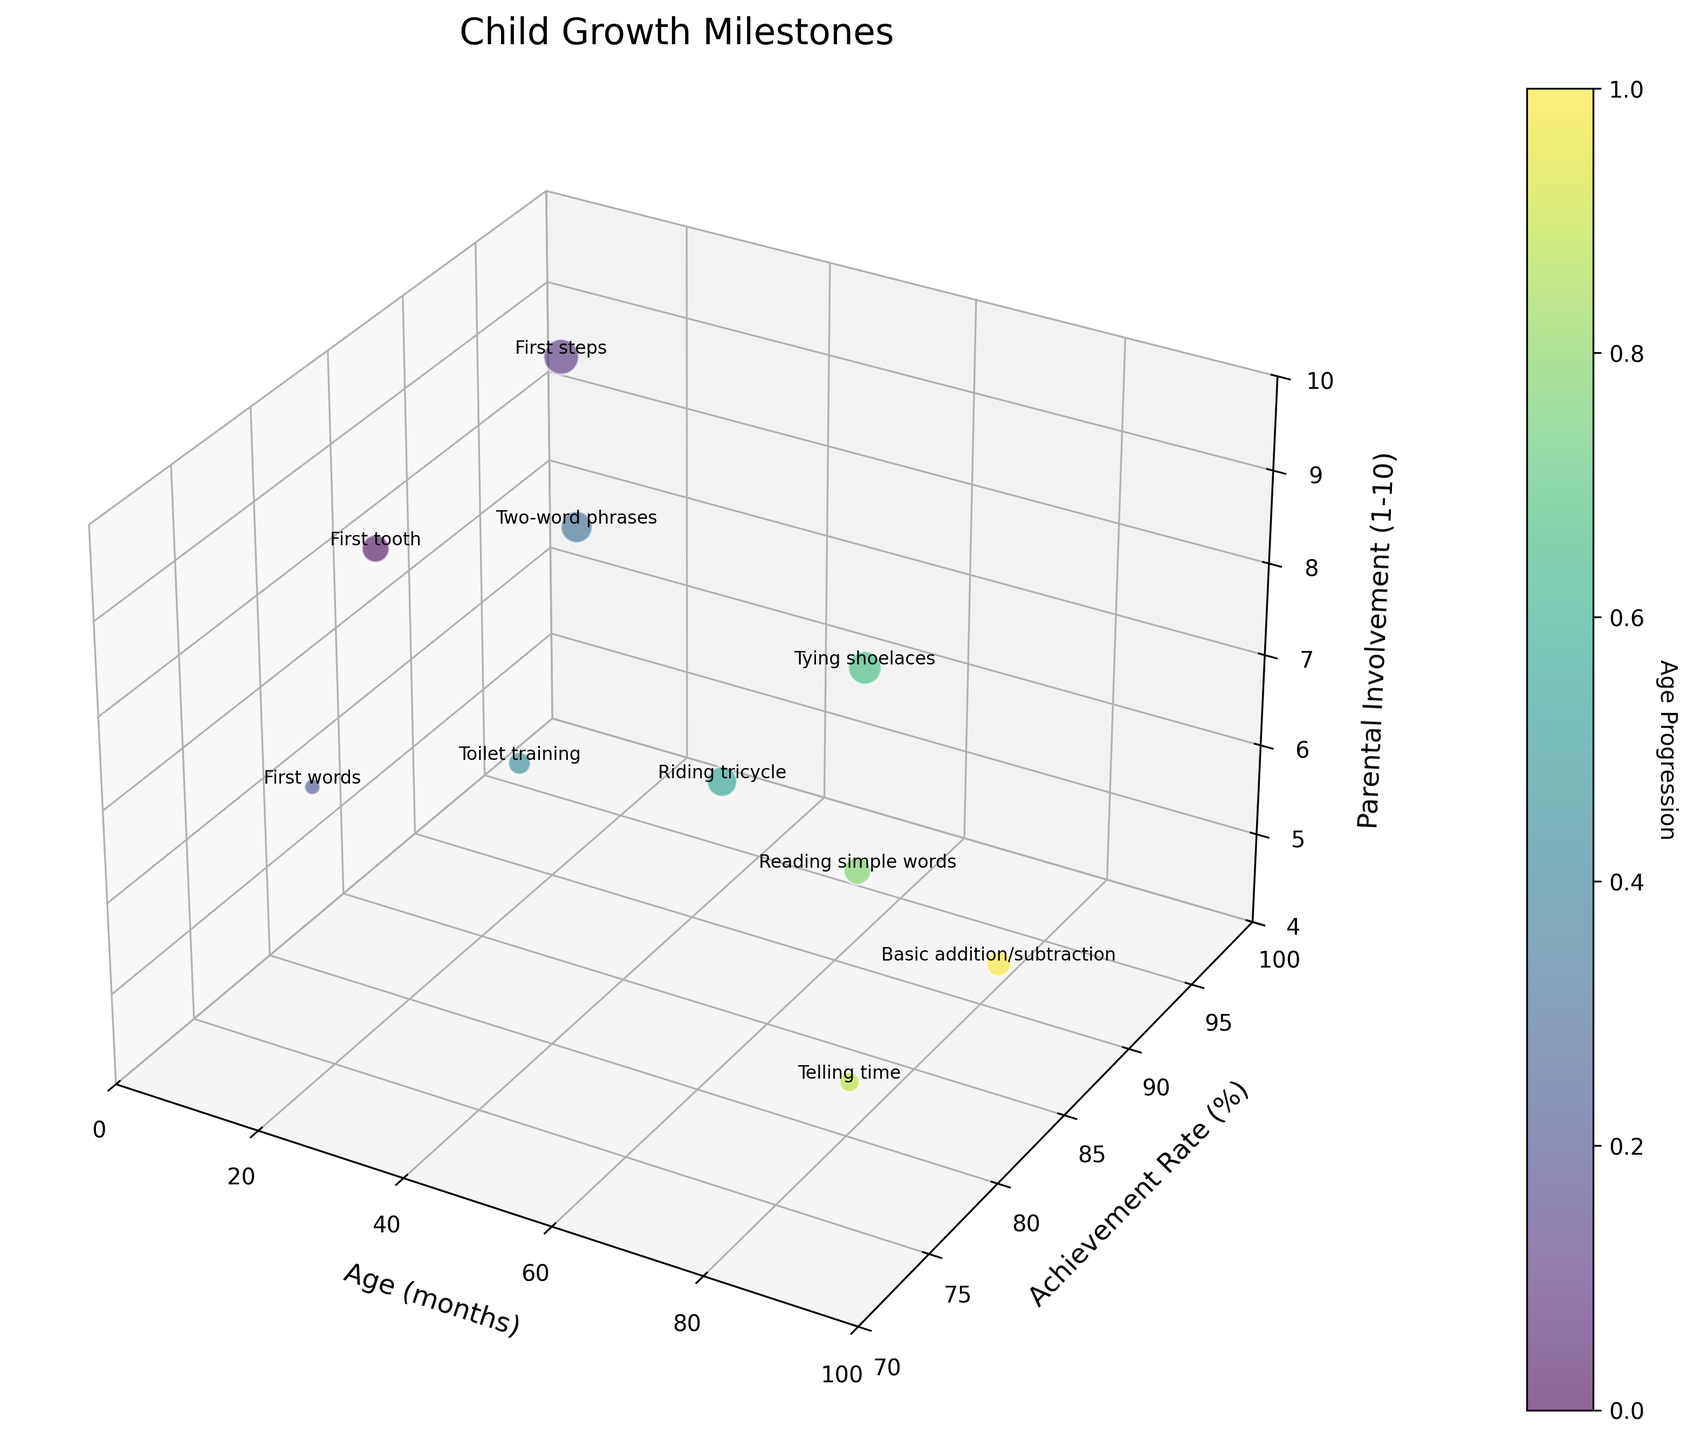Which milestone has the highest achievement rate? Look for the bubble with the highest position on the 'Achievement Rate (%)' axis (the y-axis). The highest achievement rate is at 12 months for "First steps" with a rate of 95%.
Answer: First steps What age corresponds to the milestone "Reading simple words"? Find the bubble labeled "Reading simple words" and check its position on the 'Age (months)' axis (the x-axis). This milestone occurs at 72 months.
Answer: 72 months Compare parental involvement levels for "First tooth" and "Toilet training". Which requires more parental involvement? Locate the bubbles for "First tooth" and "Toilet training" and compare their positions on the 'Parental Involvement (1-10)' axis (the z-axis). "First tooth" requires a higher involvement (8) compared to "Toilet training" (7).
Answer: First tooth Is there a milestone with both parental involvement and achievement rate exactly average? First, calculate the average parental involvement (7) and the average achievement rate (85). Then, check if any bubble aligns exactly at these averages. No milestone aligns exactly with both average values.
Answer: No Which milestone involves the youngest age? How about the oldest age? Locate the bubbles with the minimum and maximum values on the 'Age (months)' axis (the x-axis). The youngest is "First tooth" at 6 months and the oldest is "Basic addition/subtraction" at 96 months.
Answer: First tooth, Basic addition/subtraction How many milestones have an achievement rate of 90% or higher? Count the number of bubbles with a position above 90 on the 'Achievement Rate (%)' axis (the y-axis). The milestones are "First steps", "Two-word phrases", "Tying shoelaces" which makes it three points in total.
Answer: 3 milestones What's the average parental involvement level for milestones achieved in the first 24 months? Identify milestones within the first 24 months then calculate the average parental involvement of those milestones. This includes "First tooth", "First steps", "First words", and "Two-word phrases": (8 + 9 + 7 + 8) / 4 = 8.
Answer: 8 Which milestone has the smallest bubble size, and what does that signify about its achievement rate? The bubble size is tied to the achievement rate. Locate the smallest bubble in the plot and check the corresponding milestone. The milestone is "First words" which has the smallest bubble, meaning it has a relatively lower achievement rate of 75%.
Answer: First words Between "Tying shoelaces" and "Reading simple words", which has a higher achievement rate? Locate the bubbles for "Tying shoelaces" and "Reading simple words" and compare their positions on the 'Achievement Rate (%)' axis (the y-axis). "Tying shoelaces" has an achievement rate of 92%, which is higher than "Reading simple words" at 85%.
Answer: Tying shoelaces 